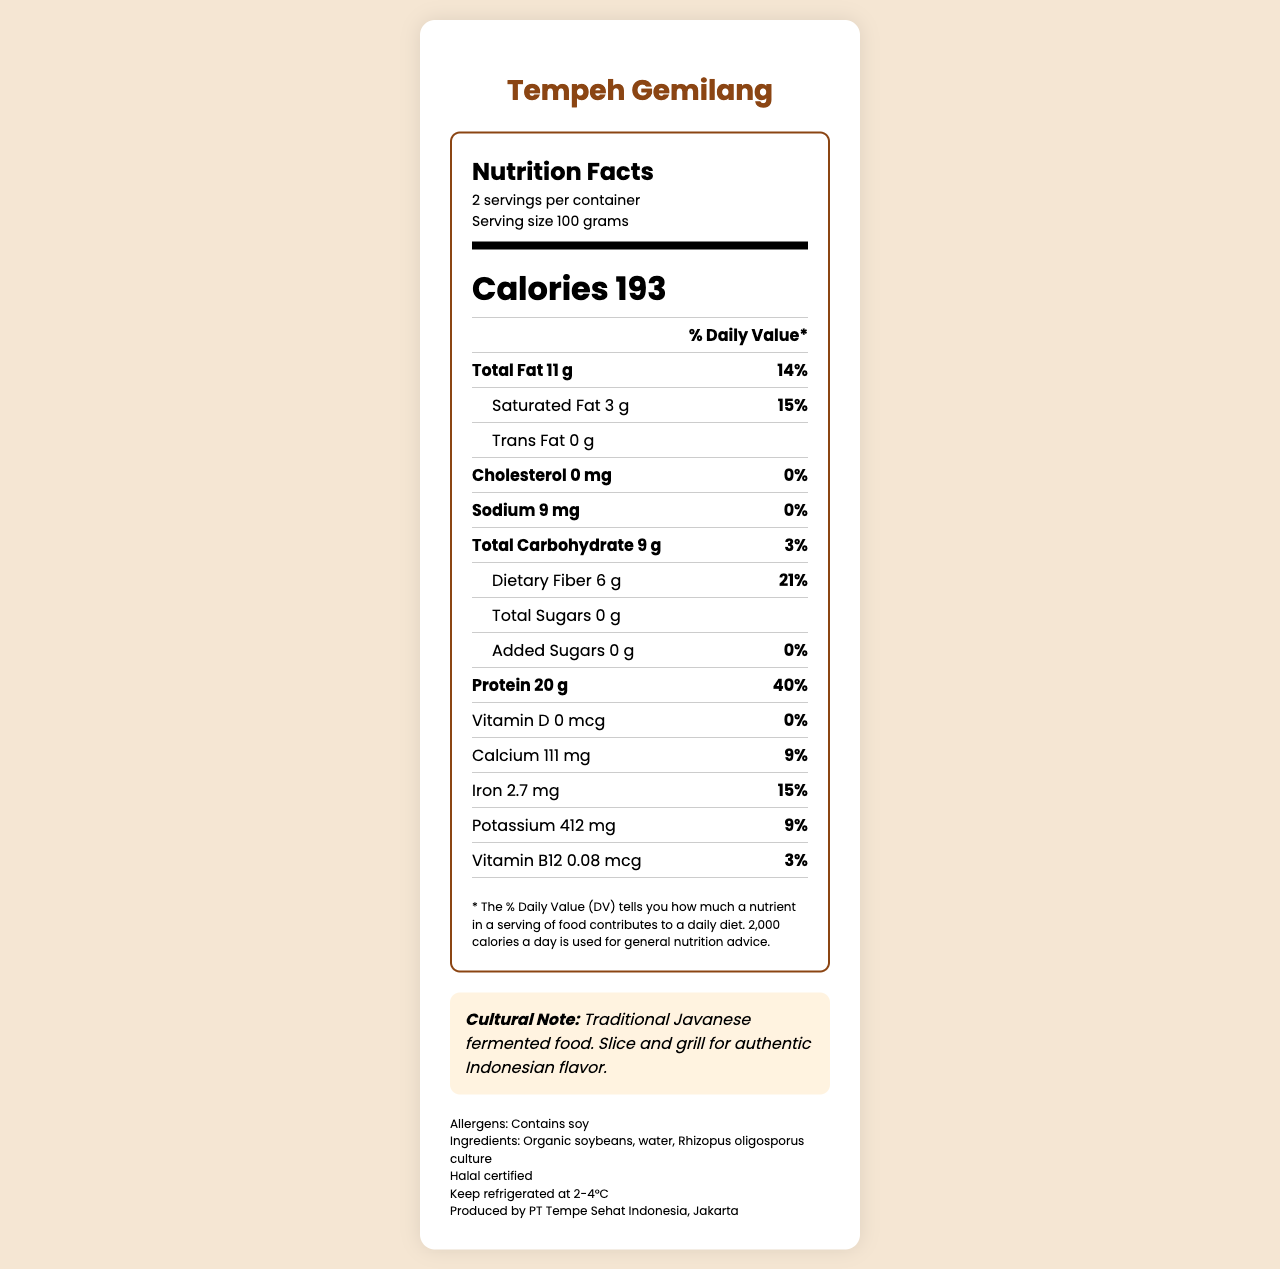what is the serving size for Tempeh Gemilang? It is mentioned under the "Nutrition Facts" section as the serving size.
Answer: 100 grams how many calories are in one serving of Tempeh Gemilang? The calories per serving are listed as 193 calories in the "Nutrition Facts" section.
Answer: 193 calories what is the total fat content for one serving? The total fat per serving is shown as 11 grams on the label.
Answer: 11 grams how much protein does Tempeh Gemilang provide per serving? The protein content per serving is listed as 20 grams on the "Nutrition Facts" label.
Answer: 20 grams how much dietary fiber is in one serving? The dietary fiber content per serving is indicated as 6 grams.
Answer: 6 grams what is the main cultural significance of Tempeh Gemilang? The cultural note at the bottom of the document states that it is a traditional Javanese fermented food.
Answer: It is a traditional Javanese fermented food. is Tempeh Gemilang halal certified? The document includes a note indicating that the product is Halal certified.
Answer: Yes what are the allergens mentioned for Tempeh Gemilang? The allergens section specifies that the product contains soy.
Answer: Contains soy which company produces Tempeh Gemilang? The manufacturer information at the bottom of the document states the producer is PT Tempe Sehat Indonesia, Jakarta.
Answer: PT Tempe Sehat Indonesia, Jakarta how should Tempeh Gemilang be stored? The storage instructions specify to keep the product refrigerated at 2-4°C.
Answer: Keep refrigerated at 2-4°C what is the total carbohydrate content per serving? A. 5 grams B. 7 grams C. 9 grams The total carbohydrate content per serving is listed as 9 grams.
Answer: C which mineral has the highest percent daily value per serving in Tempeh Gemilang? A. Calcium B. Iron C. Potassium Potassium has a 9% daily value, which is higher compared to Calcium (9%) and Iron (15%).
Answer: C does Tempeh Gemilang contain any trans fats? The document indicates that the trans fat content is 0 grams.
Answer: No does this document provide the production date for Tempeh Gemilang? The document does not include any information about the production date.
Answer: Not enough information summarize the key nutritional information and additional details for Tempeh Gemilang. The document provides a comprehensive breakdown of the nutritional content, highlighting protein and fiber content, along with detailed labeling of allergens, storage instructions, cultural context, and manufacturer information.
Answer: Tempeh Gemilang provides 193 calories per 100-gram serving, with significant macronutrients consisting of 11 grams of total fat, 20 grams of protein, and 6 grams of dietary fiber. It contains no trans fats or cholesterol, and it is halal certified. The product is allergenic to soy, should be refrigerated at 2-4°C, and has cultural significance as a traditional Javanese fermented food. 